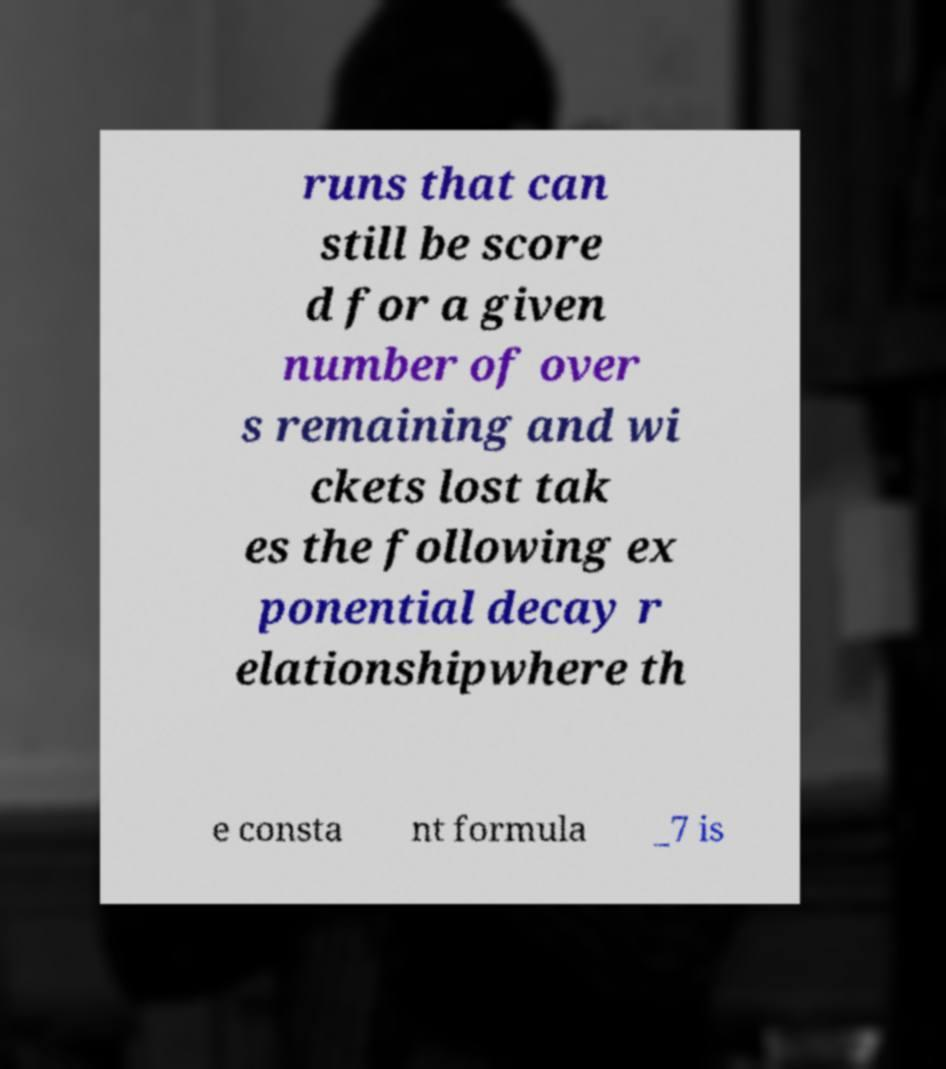Please read and relay the text visible in this image. What does it say? runs that can still be score d for a given number of over s remaining and wi ckets lost tak es the following ex ponential decay r elationshipwhere th e consta nt formula _7 is 